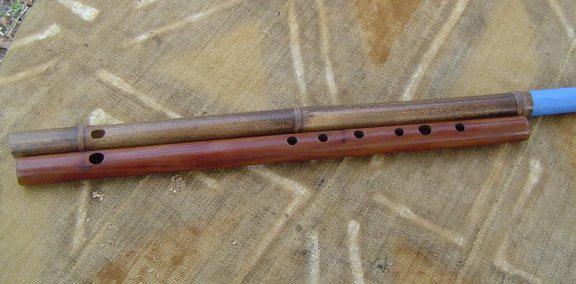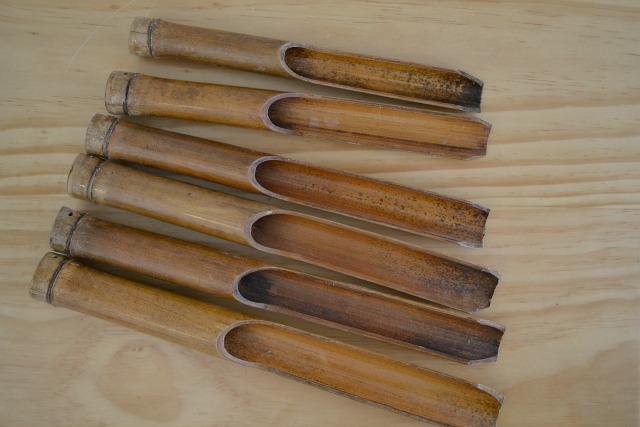The first image is the image on the left, the second image is the image on the right. Assess this claim about the two images: "One image contains a single flute displayed diagonally, and the other image contains two items displayed horizontally, at least one a bamboo stick without a row of small holes on it.". Correct or not? Answer yes or no. No. The first image is the image on the left, the second image is the image on the right. Analyze the images presented: Is the assertion "There are three flutes in total." valid? Answer yes or no. No. 